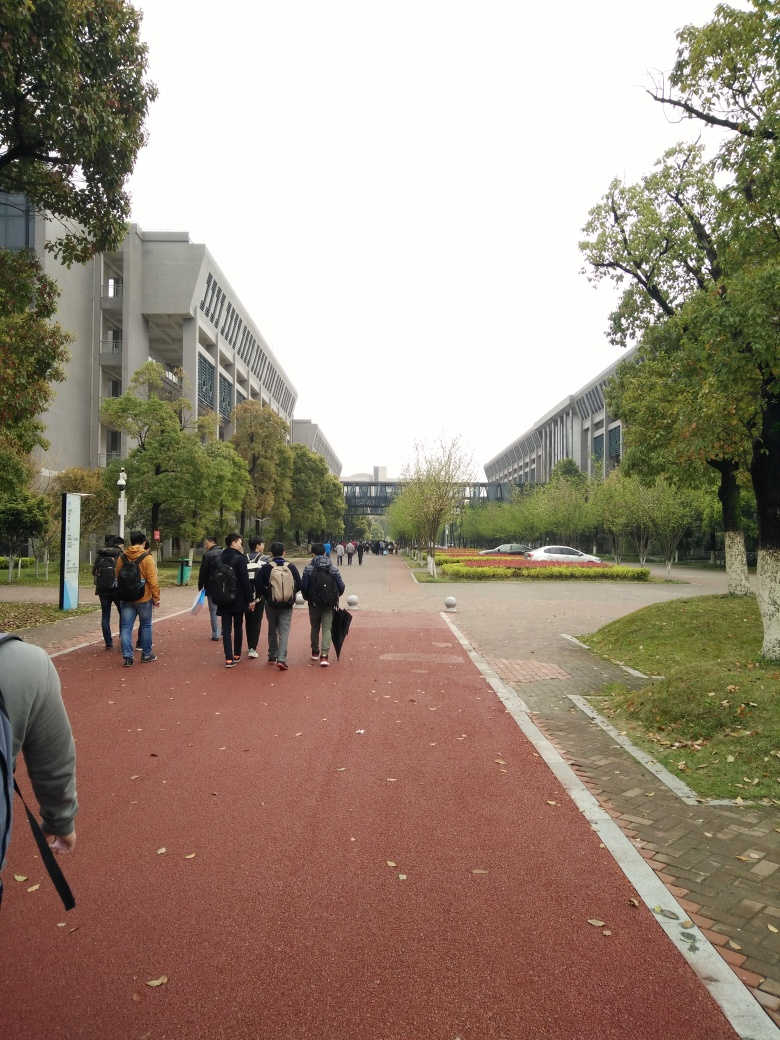What can you tell me about the architecture in the image? The buildings in the background feature modern architectural elements, with long horizontal lines and an arrangement of rectangular forms and windows that create a rhythm across their facades. The use of concrete and glass materials is prevalent, which is characteristic of many contemporary educational institutions. These structures emit a sense of robustness and functionality, designed to house a large number of students and to provide a variety of academic spaces. 